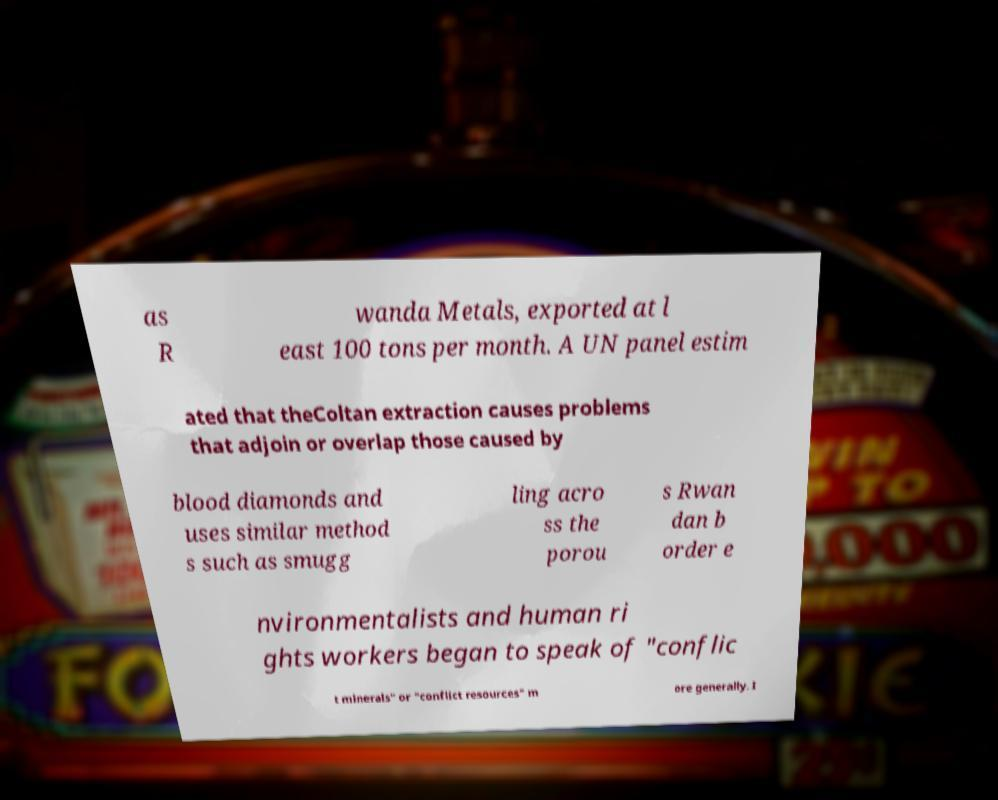For documentation purposes, I need the text within this image transcribed. Could you provide that? as R wanda Metals, exported at l east 100 tons per month. A UN panel estim ated that theColtan extraction causes problems that adjoin or overlap those caused by blood diamonds and uses similar method s such as smugg ling acro ss the porou s Rwan dan b order e nvironmentalists and human ri ghts workers began to speak of "conflic t minerals" or "conflict resources" m ore generally. I 